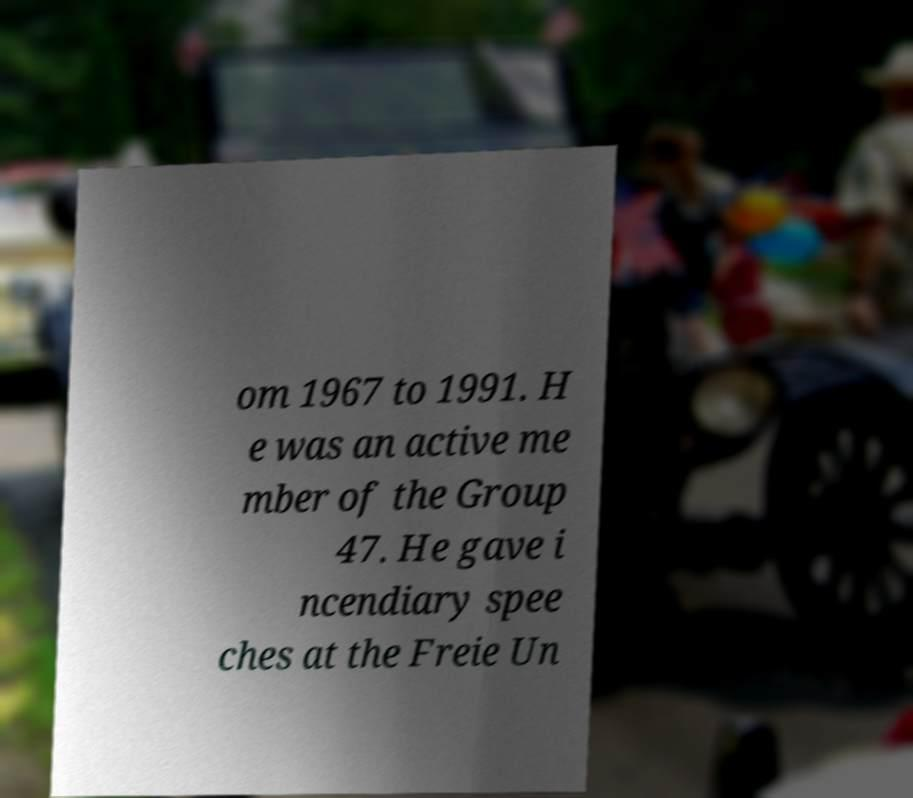Could you extract and type out the text from this image? om 1967 to 1991. H e was an active me mber of the Group 47. He gave i ncendiary spee ches at the Freie Un 